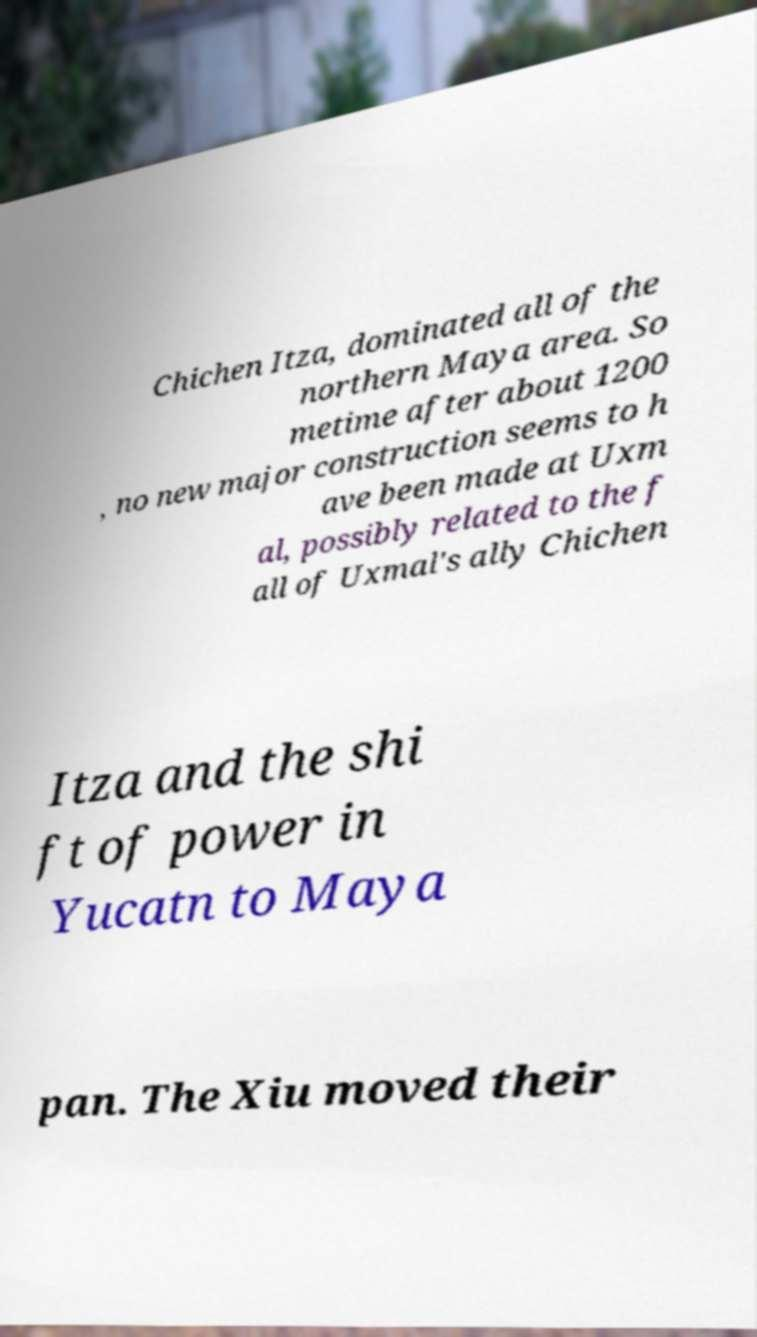Please identify and transcribe the text found in this image. Chichen Itza, dominated all of the northern Maya area. So metime after about 1200 , no new major construction seems to h ave been made at Uxm al, possibly related to the f all of Uxmal's ally Chichen Itza and the shi ft of power in Yucatn to Maya pan. The Xiu moved their 